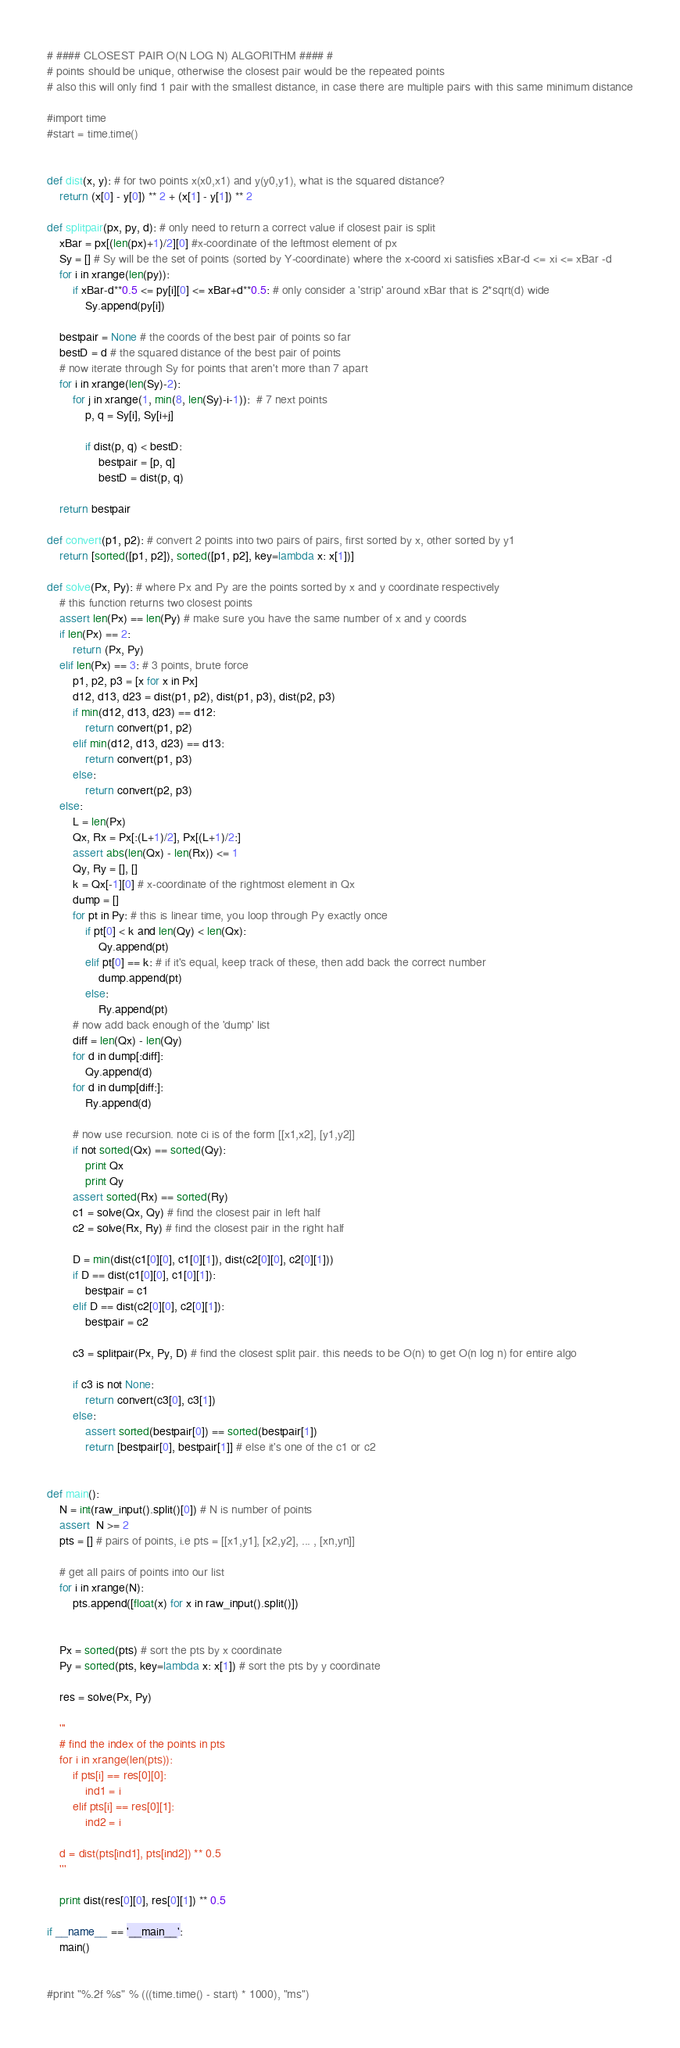<code> <loc_0><loc_0><loc_500><loc_500><_Python_># #### CLOSEST PAIR O(N LOG N) ALGORITHM #### #
# points should be unique, otherwise the closest pair would be the repeated points
# also this will only find 1 pair with the smallest distance, in case there are multiple pairs with this same minimum distance

#import time
#start = time.time()


def dist(x, y): # for two points x(x0,x1) and y(y0,y1), what is the squared distance? 
	return (x[0] - y[0]) ** 2 + (x[1] - y[1]) ** 2
	
def splitpair(px, py, d): # only need to return a correct value if closest pair is split
	xBar = px[(len(px)+1)/2][0] #x-coordinate of the leftmost element of px
	Sy = [] # Sy will be the set of points (sorted by Y-coordinate) where the x-coord xi satisfies xBar-d <= xi <= xBar -d
	for i in xrange(len(py)):
		if xBar-d**0.5 <= py[i][0] <= xBar+d**0.5: # only consider a 'strip' around xBar that is 2*sqrt(d) wide
			Sy.append(py[i])	
	
	bestpair = None # the coords of the best pair of points so far
	bestD = d # the squared distance of the best pair of points
	# now iterate through Sy for points that aren't more than 7 apart
	for i in xrange(len(Sy)-2):
		for j in xrange(1, min(8, len(Sy)-i-1)):  # 7 next points
			p, q = Sy[i], Sy[i+j]
			
			if dist(p, q) < bestD:
				bestpair = [p, q]
				bestD = dist(p, q)
				
	return bestpair
	
def convert(p1, p2): # convert 2 points into two pairs of pairs, first sorted by x, other sorted by y1
	return [sorted([p1, p2]), sorted([p1, p2], key=lambda x: x[1])]
	
def solve(Px, Py): # where Px and Py are the points sorted by x and y coordinate respectively
	# this function returns two closest points
	assert len(Px) == len(Py) # make sure you have the same number of x and y coords
	if len(Px) == 2:
		return (Px, Py)
	elif len(Px) == 3: # 3 points, brute force
		p1, p2, p3 = [x for x in Px]
		d12, d13, d23 = dist(p1, p2), dist(p1, p3), dist(p2, p3)
		if min(d12, d13, d23) == d12: 
			return convert(p1, p2)
		elif min(d12, d13, d23) == d13: 
			return convert(p1, p3)
		else: 
			return convert(p2, p3)
	else:
		L = len(Px)
		Qx, Rx = Px[:(L+1)/2], Px[(L+1)/2:]
		assert abs(len(Qx) - len(Rx)) <= 1
		Qy, Ry = [], []
		k = Qx[-1][0] # x-coordinate of the rightmost element in Qx
		dump = []
		for pt in Py: # this is linear time, you loop through Py exactly once
			if pt[0] < k and len(Qy) < len(Qx):
				Qy.append(pt)
			elif pt[0] == k: # if it's equal, keep track of these, then add back the correct number
				dump.append(pt)
			else:
				Ry.append(pt)
		# now add back enough of the 'dump' list
		diff = len(Qx) - len(Qy)
		for d in dump[:diff]:
			Qy.append(d)
		for d in dump[diff:]:
			Ry.append(d)
		
		# now use recursion. note ci is of the form [[x1,x2], [y1,y2]]
		if not sorted(Qx) == sorted(Qy):
			print Qx
			print Qy
		assert sorted(Rx) == sorted(Ry)
		c1 = solve(Qx, Qy) # find the closest pair in left half
		c2 = solve(Rx, Ry) # find the closest pair in the right half
		
		D = min(dist(c1[0][0], c1[0][1]), dist(c2[0][0], c2[0][1]))
		if D == dist(c1[0][0], c1[0][1]):
			bestpair = c1
		elif D == dist(c2[0][0], c2[0][1]):
			bestpair = c2
		
		c3 = splitpair(Px, Py, D) # find the closest split pair. this needs to be O(n) to get O(n log n) for entire algo
		
		if c3 is not None: 
			return convert(c3[0], c3[1])
		else:
			assert sorted(bestpair[0]) == sorted(bestpair[1])
			return [bestpair[0], bestpair[1]] # else it's one of the c1 or c2
		
		
def main():
	N = int(raw_input().split()[0]) # N is number of points
	assert  N >= 2
	pts = [] # pairs of points, i.e pts = [[x1,y1], [x2,y2], ... , [xn,yn]]
	
	# get all pairs of points into our list
	for i in xrange(N):
		pts.append([float(x) for x in raw_input().split()])
		
	
	Px = sorted(pts) # sort the pts by x coordinate
	Py = sorted(pts, key=lambda x: x[1]) # sort the pts by y coordinate
	
	res = solve(Px, Py)
	
	'''
	# find the index of the points in pts
	for i in xrange(len(pts)):
		if pts[i] == res[0][0]:
			ind1 = i
		elif pts[i] == res[0][1]:
			ind2 = i
			
	d = dist(pts[ind1], pts[ind2]) ** 0.5
	'''
	
	print dist(res[0][0], res[0][1]) ** 0.5

if __name__ == '__main__':
	main()


#print "%.2f %s" % (((time.time() - start) * 1000), "ms")</code> 